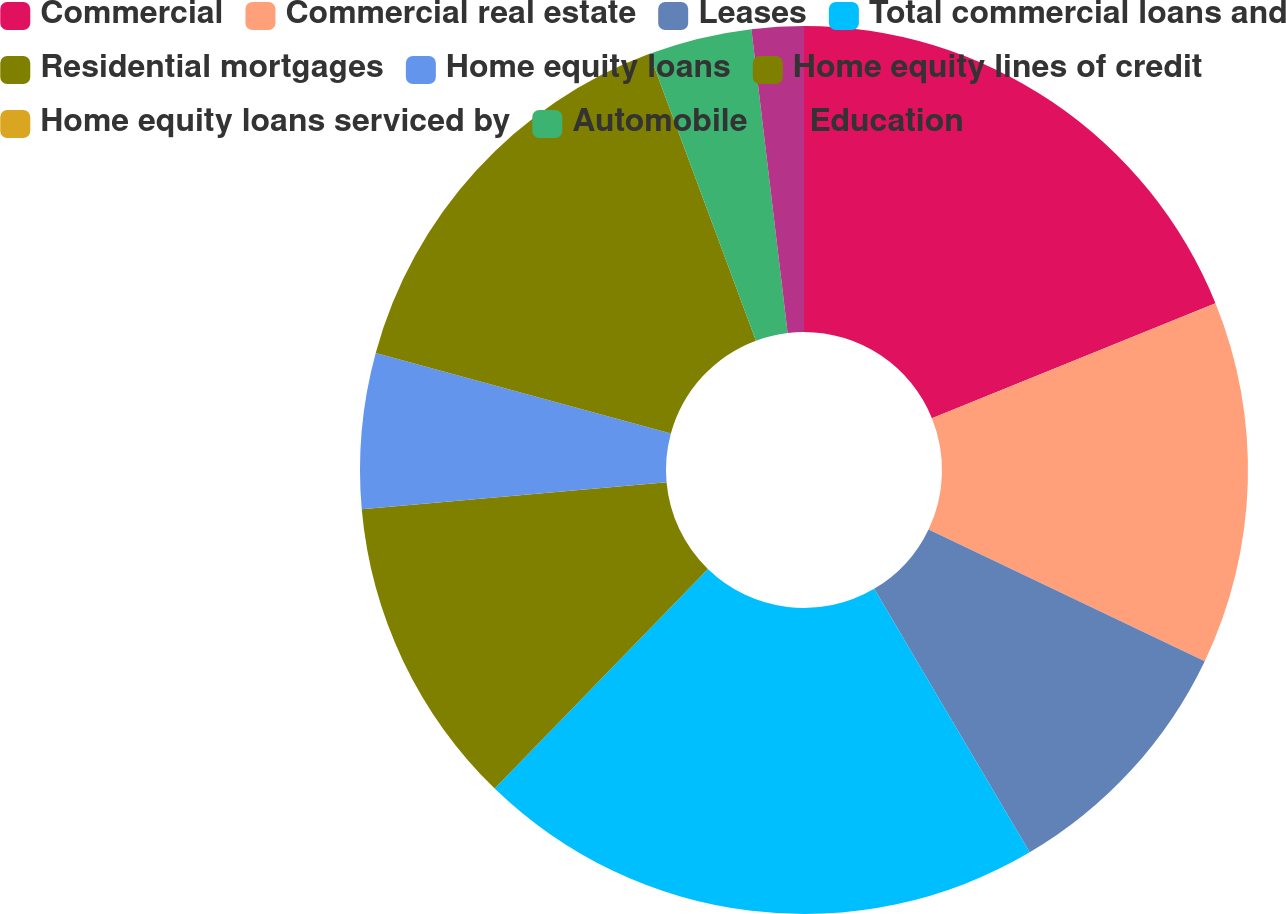Convert chart to OTSL. <chart><loc_0><loc_0><loc_500><loc_500><pie_chart><fcel>Commercial<fcel>Commercial real estate<fcel>Leases<fcel>Total commercial loans and<fcel>Residential mortgages<fcel>Home equity loans<fcel>Home equity lines of credit<fcel>Home equity loans serviced by<fcel>Automobile<fcel>Education<nl><fcel>18.87%<fcel>13.21%<fcel>9.43%<fcel>20.75%<fcel>11.32%<fcel>5.66%<fcel>15.09%<fcel>0.0%<fcel>3.77%<fcel>1.89%<nl></chart> 